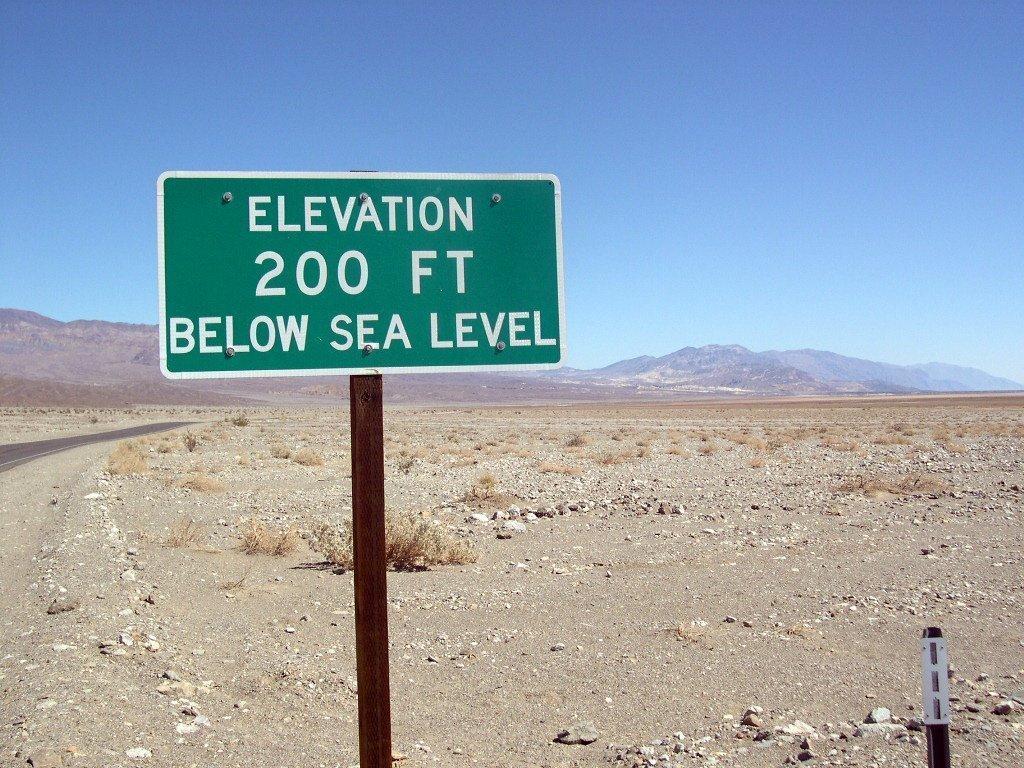What is the elevation?
Make the answer very short. 200 ft. What does the sign say the elevation is below?
Provide a short and direct response. Sea level. What does it say in the bottom row of text on this sign?
Ensure brevity in your answer.  Below sea level. 